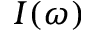<formula> <loc_0><loc_0><loc_500><loc_500>I ( \omega )</formula> 